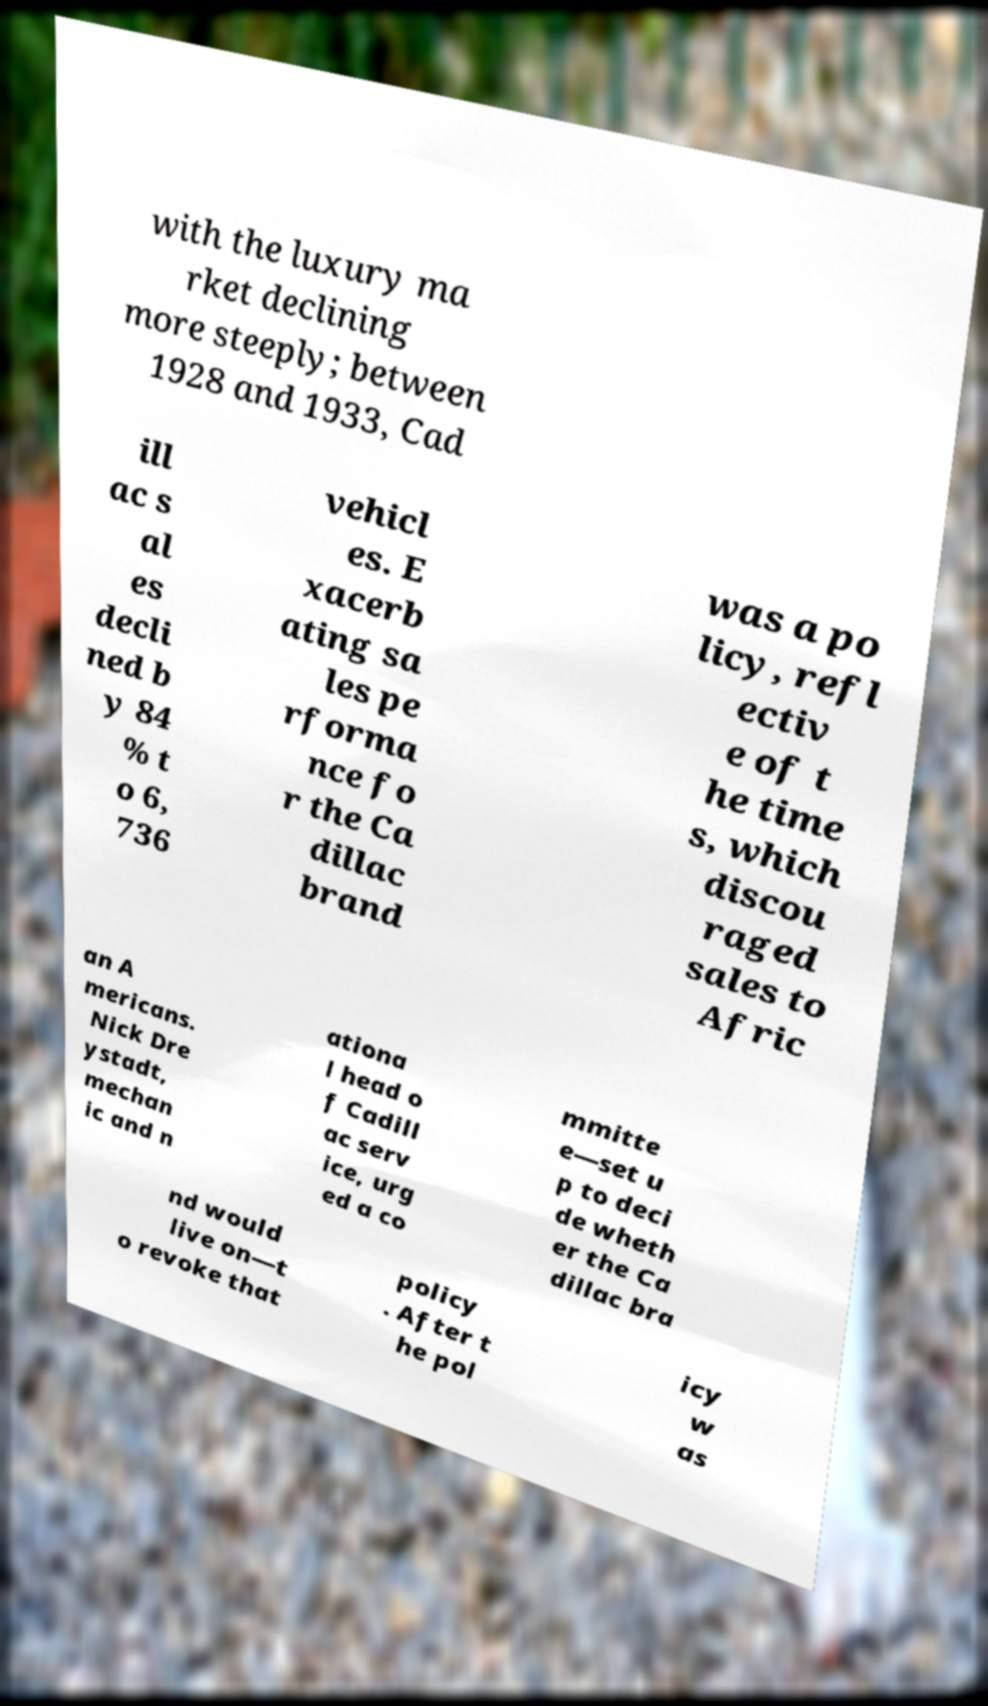Could you extract and type out the text from this image? with the luxury ma rket declining more steeply; between 1928 and 1933, Cad ill ac s al es decli ned b y 84 % t o 6, 736 vehicl es. E xacerb ating sa les pe rforma nce fo r the Ca dillac brand was a po licy, refl ectiv e of t he time s, which discou raged sales to Afric an A mericans. Nick Dre ystadt, mechan ic and n ationa l head o f Cadill ac serv ice, urg ed a co mmitte e—set u p to deci de wheth er the Ca dillac bra nd would live on—t o revoke that policy . After t he pol icy w as 